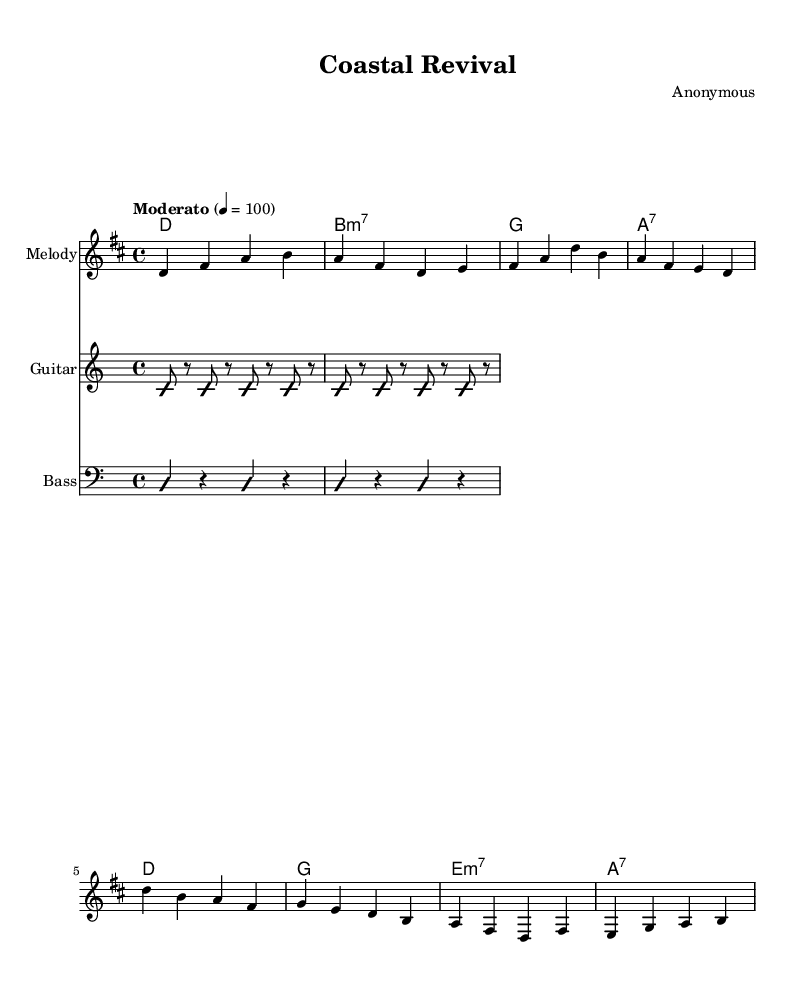What is the key signature of this music? The key signature is D major, which has two sharps (F# and C#). This can be identified by looking at the key signature symbol at the beginning of the sheet music.
Answer: D major What is the time signature of this music? The time signature is 4/4, indicated at the beginning of the score. This means there are four beats in each measure and the quarter note gets one beat.
Answer: 4/4 What is the tempo marking for this piece? The tempo marking is "Moderato," which is often used to indicate a moderately slow tempo. This is typically noted above the staff in the sheet music.
Answer: Moderato What is the structure of the song? The song has two main sections: a Verse and a Chorus. This is evident as the lyrics are divided into two distinct parts, corresponding to the musical phrases.
Answer: Verse and Chorus How many measures are in the verse section? There are four measures in the verse section. By counting the vertical lines separating the measures in the melody part, we can confirm the number of measures.
Answer: 4 What is the main theme of the lyrics? The main theme of the lyrics is the restoration of historic coastal towns. This is derived from reading the words in the verse, which focus on preservation and architecture.
Answer: Restoration of historic coastal towns What types of musical techniques are mentioned in the lyrics? The lyrics mention "modern conservation techniques." This is a specific technique that refers to methods used in preserving historical structures, indicated in the chorus.
Answer: Modern conservation techniques 